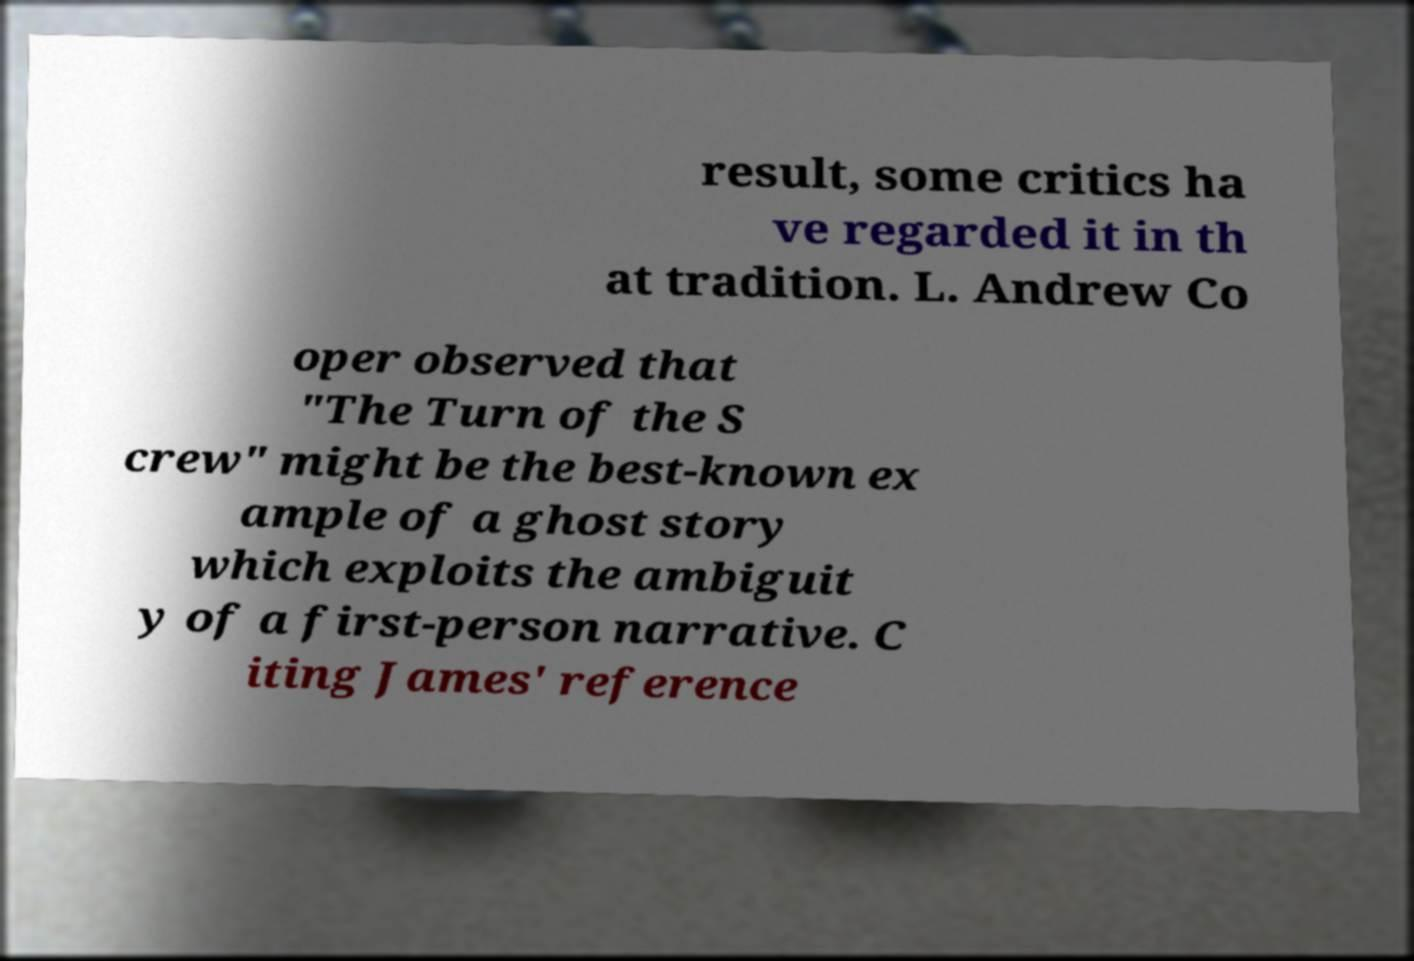There's text embedded in this image that I need extracted. Can you transcribe it verbatim? result, some critics ha ve regarded it in th at tradition. L. Andrew Co oper observed that "The Turn of the S crew" might be the best-known ex ample of a ghost story which exploits the ambiguit y of a first-person narrative. C iting James' reference 